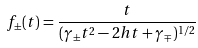Convert formula to latex. <formula><loc_0><loc_0><loc_500><loc_500>f _ { \pm } ( t ) = \frac { t } { ( \gamma _ { \pm } t ^ { 2 } - 2 h t + \gamma _ { \mp } ) ^ { 1 / 2 } }</formula> 